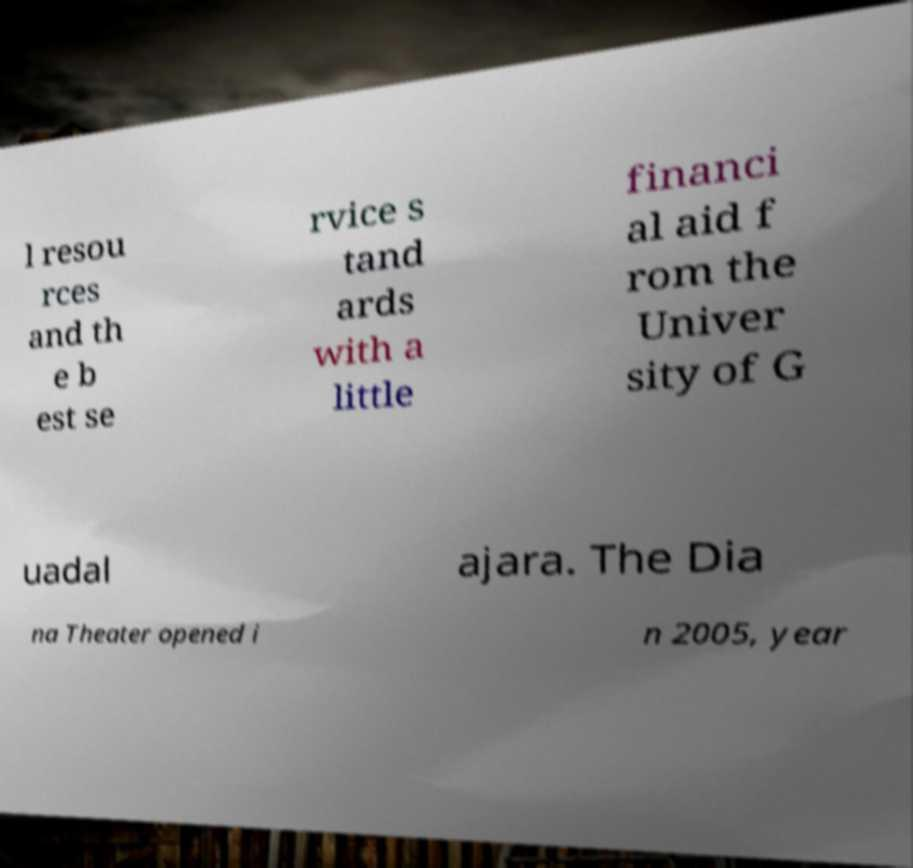Please identify and transcribe the text found in this image. l resou rces and th e b est se rvice s tand ards with a little financi al aid f rom the Univer sity of G uadal ajara. The Dia na Theater opened i n 2005, year 